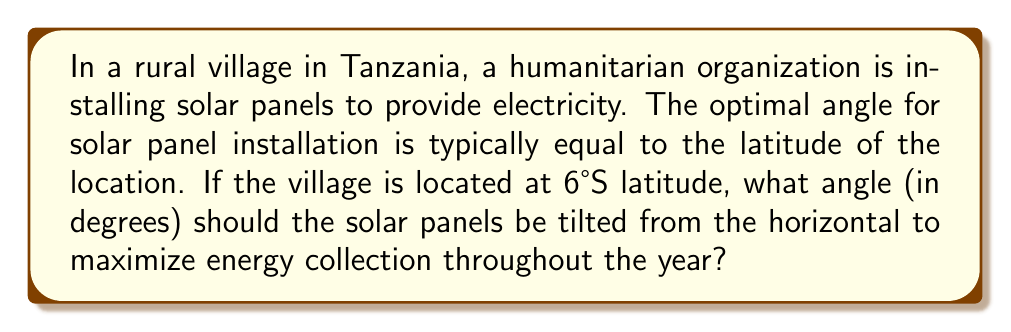Show me your answer to this math problem. To solve this problem, we need to follow these steps:

1. Understand the relationship between latitude and optimal solar panel angle:
   The optimal tilt angle for solar panels is generally equal to the latitude of the location.

2. Identify the latitude of the village:
   The village is located at 6°S latitude.

3. Convert the latitude to a positive angle:
   Since we're in the Southern Hemisphere, we need to use the absolute value of the latitude.
   $|{-6°}| = 6°$

4. Set the optimal tilt angle equal to the latitude:
   Optimal tilt angle = $6°$

Therefore, the solar panels should be tilted at a $6°$ angle from the horizontal to maximize energy collection throughout the year.

[asy]
import geometry;

size(200);
draw((0,0)--(100,0), arrow=Arrow);
draw((0,0)--(0,100), arrow=Arrow);
draw((0,0)--(100,10.5), arrow=Arrow);

label("Horizontal", (50,-10));
label("Vertical", (-10,50));
label("Solar Panel", (50,15));
label("6°", (10,5));

draw(arc((0,0),10,0,6), arrow=Arrow);
[/asy]
Answer: $6°$ 